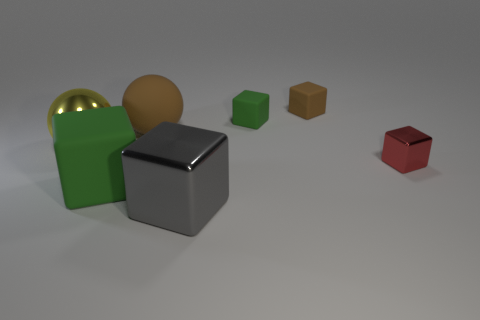Subtract all brown blocks. How many blocks are left? 4 Subtract all tiny red shiny blocks. How many blocks are left? 4 Add 1 green matte cubes. How many objects exist? 8 Subtract all blue cubes. Subtract all purple balls. How many cubes are left? 5 Subtract all blocks. How many objects are left? 2 Add 6 large brown matte objects. How many large brown matte objects exist? 7 Subtract 0 cyan cylinders. How many objects are left? 7 Subtract all tiny cyan matte cylinders. Subtract all large gray cubes. How many objects are left? 6 Add 3 blocks. How many blocks are left? 8 